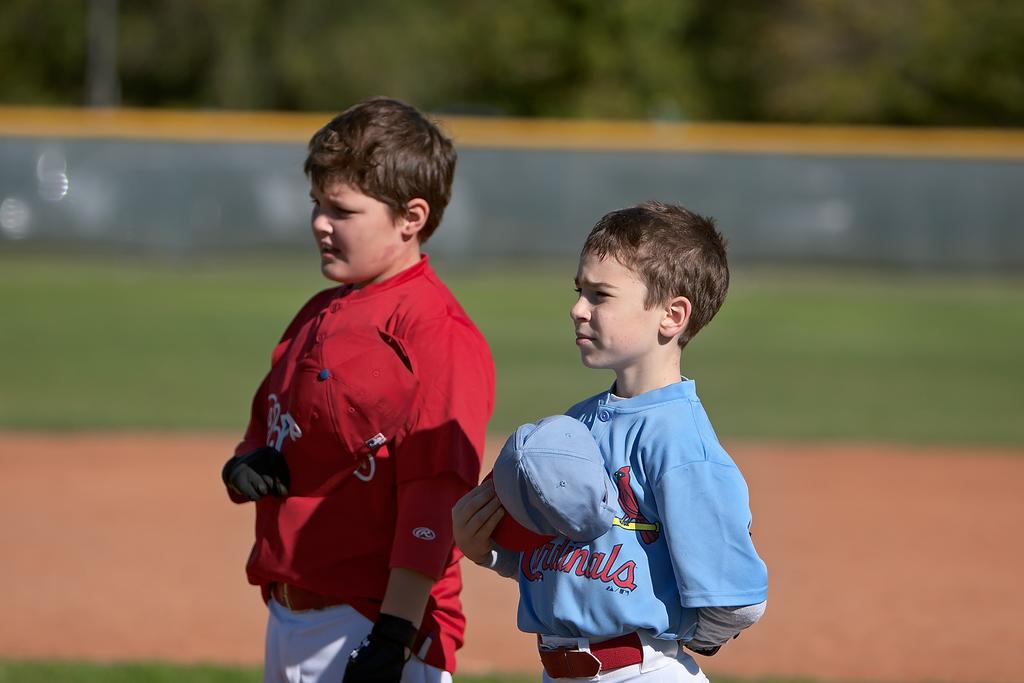<image>
Provide a brief description of the given image. A young boy wears a light blue shirt with Cardinals on the front. 